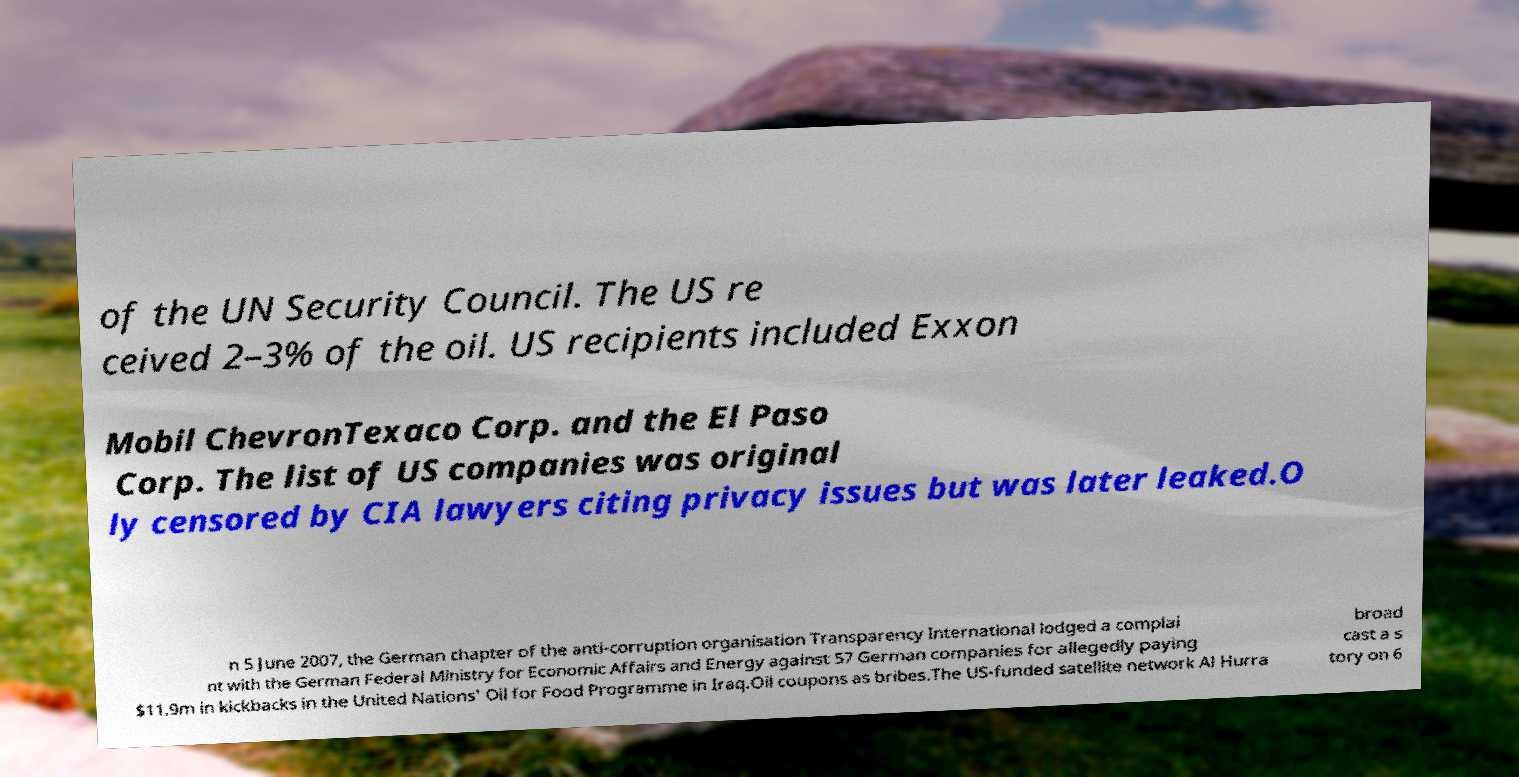Can you read and provide the text displayed in the image?This photo seems to have some interesting text. Can you extract and type it out for me? of the UN Security Council. The US re ceived 2–3% of the oil. US recipients included Exxon Mobil ChevronTexaco Corp. and the El Paso Corp. The list of US companies was original ly censored by CIA lawyers citing privacy issues but was later leaked.O n 5 June 2007, the German chapter of the anti-corruption organisation Transparency International lodged a complai nt with the German Federal Ministry for Economic Affairs and Energy against 57 German companies for allegedly paying $11.9m in kickbacks in the United Nations' Oil for Food Programme in Iraq.Oil coupons as bribes.The US-funded satellite network Al Hurra broad cast a s tory on 6 